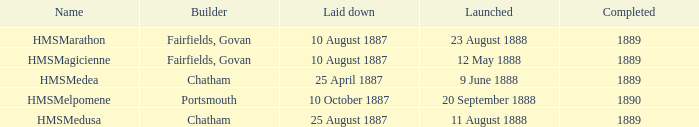Which architect completed before 1890 and initiated on 9 june 1888? Chatham. 